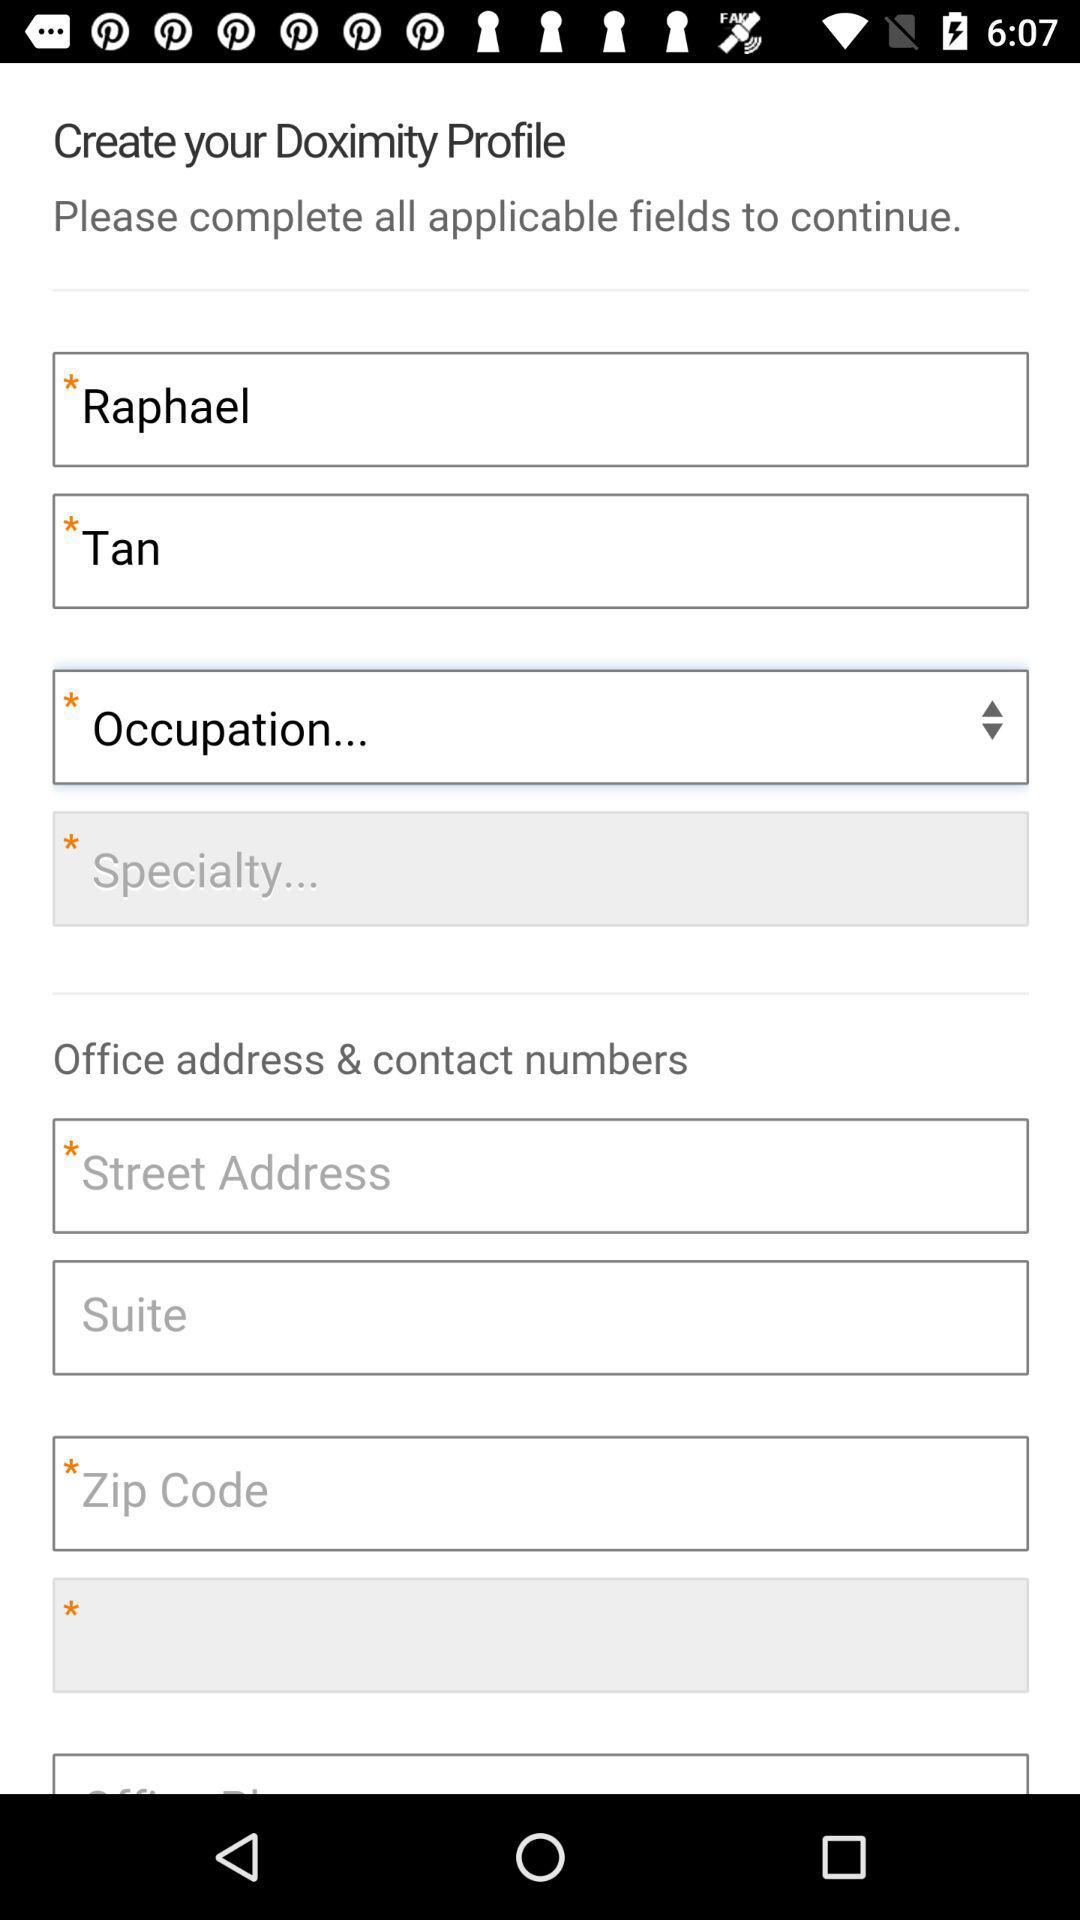What is the first name? the first name is Raphael. 